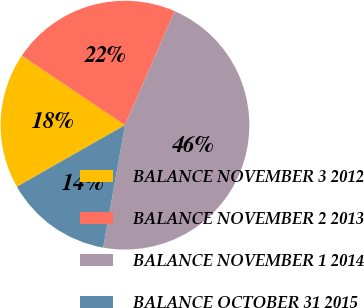<chart> <loc_0><loc_0><loc_500><loc_500><pie_chart><fcel>BALANCE NOVEMBER 3 2012<fcel>BALANCE NOVEMBER 2 2013<fcel>BALANCE NOVEMBER 1 2014<fcel>BALANCE OCTOBER 31 2015<nl><fcel>17.68%<fcel>22.11%<fcel>46.26%<fcel>13.96%<nl></chart> 